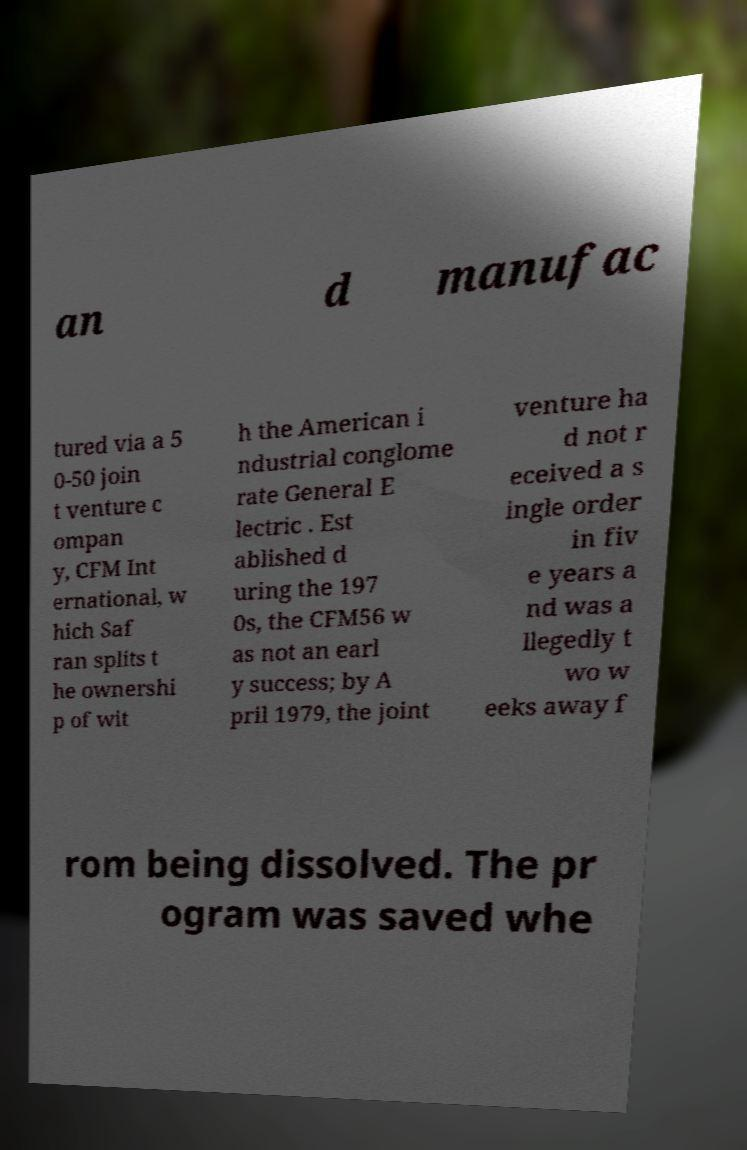There's text embedded in this image that I need extracted. Can you transcribe it verbatim? an d manufac tured via a 5 0-50 join t venture c ompan y, CFM Int ernational, w hich Saf ran splits t he ownershi p of wit h the American i ndustrial conglome rate General E lectric . Est ablished d uring the 197 0s, the CFM56 w as not an earl y success; by A pril 1979, the joint venture ha d not r eceived a s ingle order in fiv e years a nd was a llegedly t wo w eeks away f rom being dissolved. The pr ogram was saved whe 